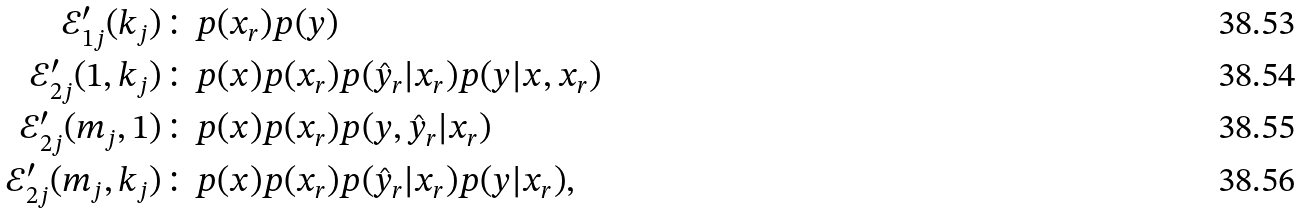<formula> <loc_0><loc_0><loc_500><loc_500>\mathcal { E } ^ { \prime } _ { 1 j } ( k _ { j } ) & \colon p ( x _ { r } ) p ( y ) \\ \mathcal { E } ^ { \prime } _ { 2 j } ( 1 , k _ { j } ) & \colon p ( x ) p ( x _ { r } ) p ( \hat { y } _ { r } | x _ { r } ) p ( y | x , x _ { r } ) \\ \mathcal { E } ^ { \prime } _ { 2 j } ( m _ { j } , 1 ) & \colon p ( x ) p ( x _ { r } ) p ( y , \hat { y } _ { r } | x _ { r } ) \\ \mathcal { E } ^ { \prime } _ { 2 j } ( m _ { j } , k _ { j } ) & \colon p ( x ) p ( x _ { r } ) p ( \hat { y } _ { r } | x _ { r } ) p ( y | x _ { r } ) ,</formula> 